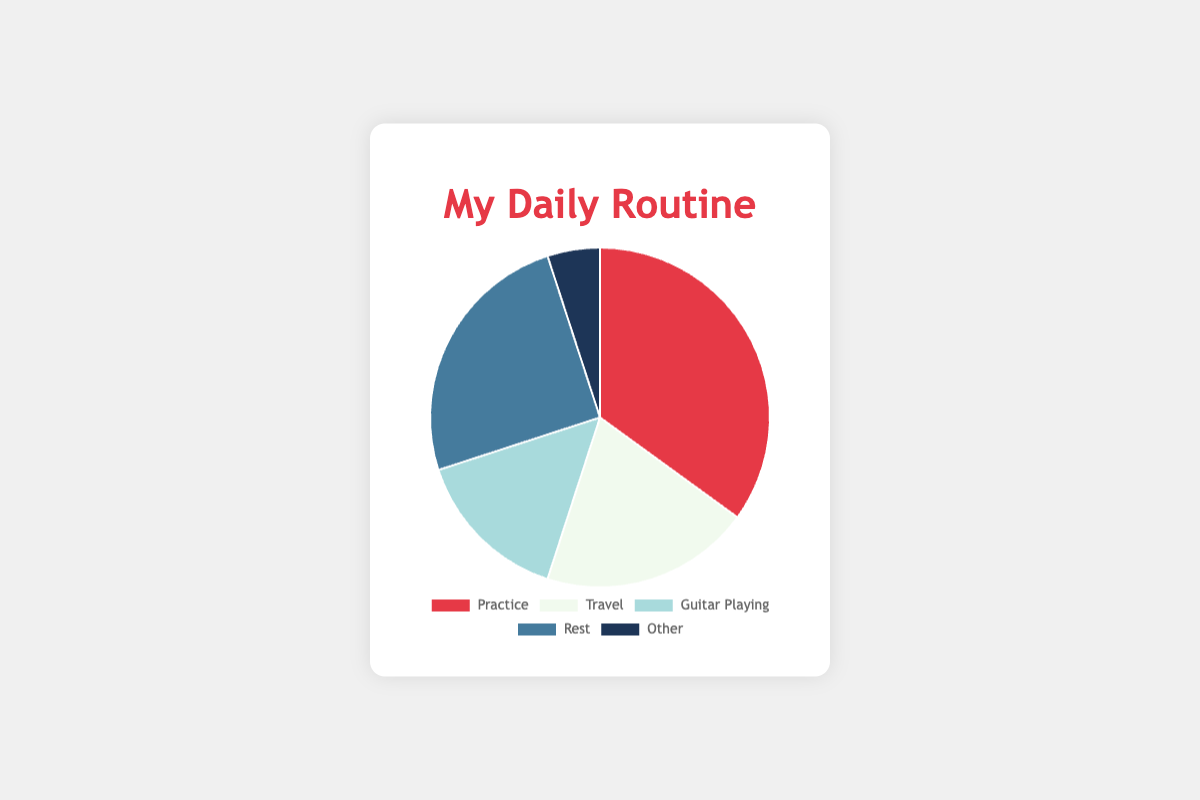What activity takes up the highest percentage of your daily routine? Look at the segments of the pie chart and identify the one with the largest portion. The "Practice" segment has the largest slice, corresponding to 35%.
Answer: Practice Which activity is the least time-consuming in your daily routine? Examine the segments to find the smallest slice of the pie chart. "Other" is the smallest segment with 5%.
Answer: Other If you combine the time spent on Travel and Practice, what percentage of your day is that? Add the percentages for Travel (20%) and Practice (35%). 20% + 35% = 55%.
Answer: 55% Is the time spent resting greater than the time spent traveling? Compare the segments for Rest and Travel. Rest is 25% and Travel is 20%, so Rest is greater.
Answer: Yes How much more time do you spend on Practice compared to Guitar Playing? Subtract the percentage of Guitar Playing (15%) from the percentage of Practice (35%). 35% - 15% = 20%.
Answer: 20% What color represents the "Rest" segment in the pie chart? Identify the segment labeled "Rest" and observe its color. The "Rest" segment is blue.
Answer: Blue What is the combined percentage for non-sport activities (Guitar Playing, Rest, and Other)? Add the percentages for Guitar Playing (15%), Rest (25%), and Other (5%). 15% + 25% + 5% = 45%.
Answer: 45% If you had to reduce time from "Practice" to increase "Guitar Playing," how much would you need to reduce Practice to make them equal? Subtract the current Guitar Playing percentage (15%) from the Practice percentage (35%). 35% - 15% = 20%. You need to reduce Practice time by 20% to match Guitar Playing percentage.
Answer: 20% Which activities make up the majority of your day (more than 50%)? Look at the percentages and combine them to see which ones surpass 50%. Practice (35%) and Rest (25%) together make 60%, which is more than 50%.
Answer: Practice and Rest Are there any activities that occupy exactly one-quarter of your time? Identify any segments that are exactly 25% of the pie chart. The "Rest" segment is exactly 25%.
Answer: Rest 